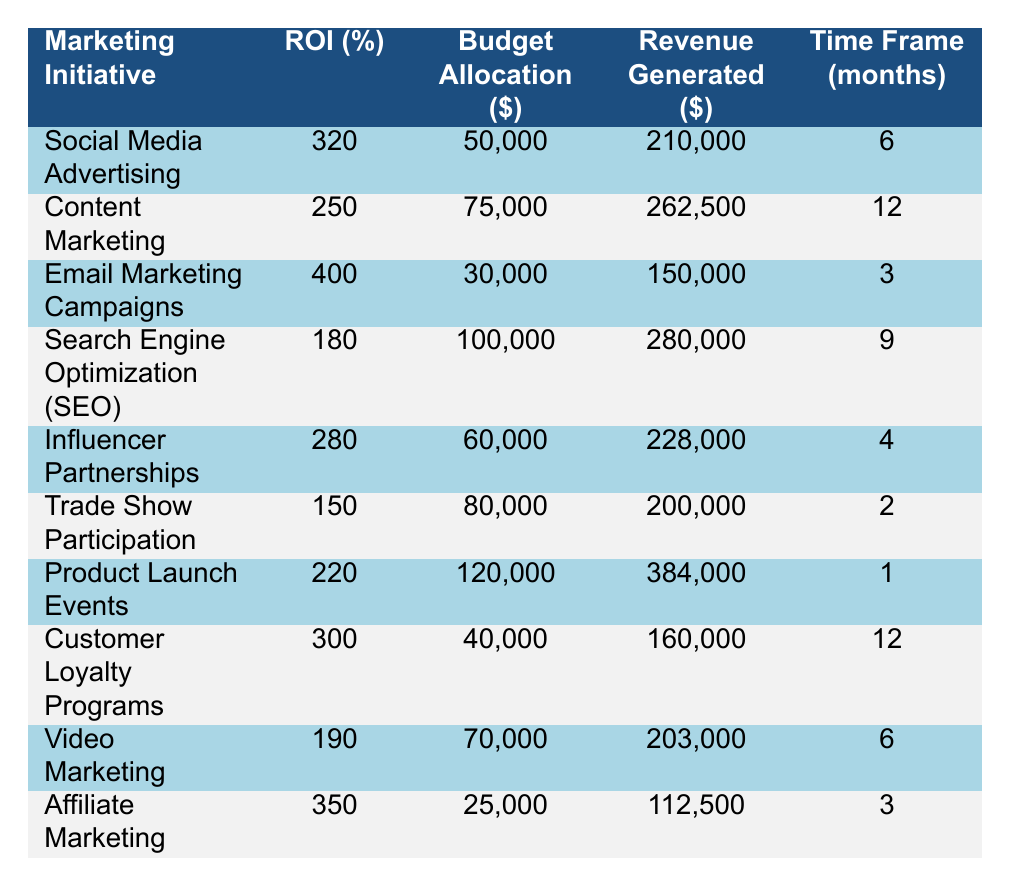What is the ROI percentage of Email Marketing Campaigns? The table shows that Email Marketing Campaigns has an ROI percentage of 400.
Answer: 400 Which marketing initiative had the highest revenue generated? By looking at the Revenue Generated column, Product Launch Events generated the highest revenue at 384,000.
Answer: 384,000 How much budget allocation was dedicated to Social Media Advertising? According to the table, Social Media Advertising received a budget allocation of 50,000.
Answer: 50,000 What is the total revenue generated from all marketing initiatives? Summing the revenue generated: 210,000 + 262,500 + 150,000 + 280,000 + 228,000 + 200,000 + 384,000 + 160,000 + 203,000 + 112,500 gives a total of 1,990,000.
Answer: 1,990,000 Is the ROI for Search Engine Optimization higher than 200%? The table shows that the ROI for SEO is 180%, which is not higher than 200%.
Answer: No Calculate the average ROI for all initiatives. Adding all ROI values: (320 + 250 + 400 + 180 + 280 + 150 + 220 + 300 + 190 + 350) = 2,340. Dividing by the number of initiatives (10) gives an average ROI of 234.
Answer: 234 Which initiative had the lowest budget allocation? The table indicates that Affiliate Marketing had the lowest budget allocation at 25,000.
Answer: 25,000 What is the difference in ROI between Social Media Advertising and Influencer Partnerships? The ROI for Social Media Advertising is 320 and for Influencer Partnerships it is 280, so the difference is 320 - 280 = 40.
Answer: 40 How many months does the Customer Loyalty Programs initiative run for? The Time Frame for Customer Loyalty Programs is listed as 12 months in the table.
Answer: 12 Does Email Marketing Campaigns generate more revenue than Video Marketing? Email Marketing Campaigns generates 150,000 while Video Marketing generates 203,000, so yes, Video Marketing generates more revenue.
Answer: Yes 